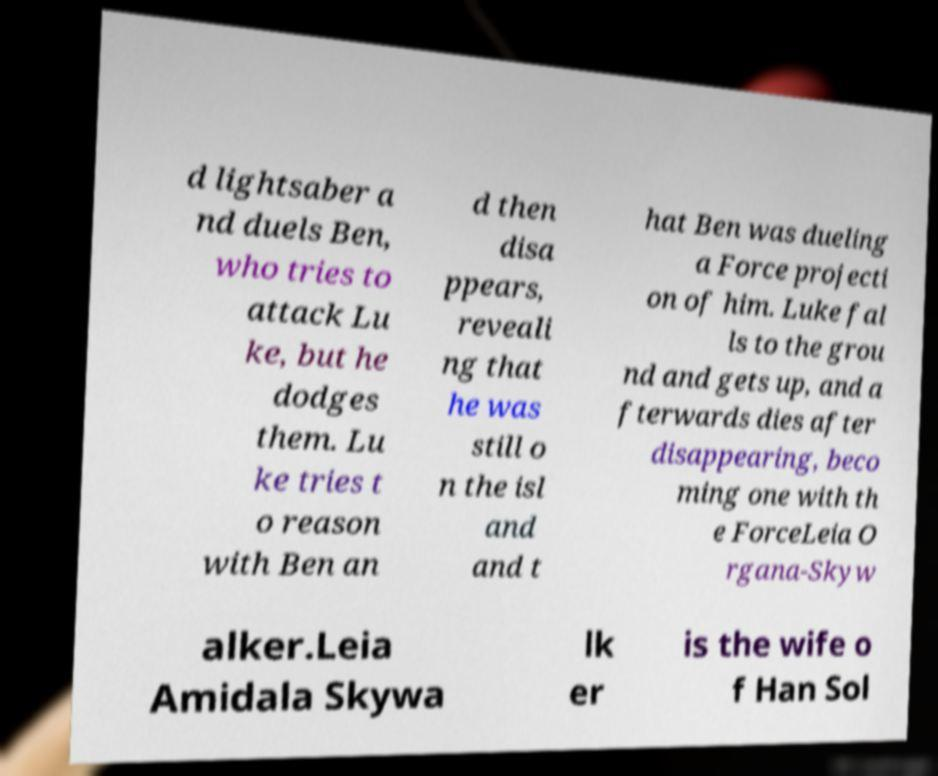What messages or text are displayed in this image? I need them in a readable, typed format. d lightsaber a nd duels Ben, who tries to attack Lu ke, but he dodges them. Lu ke tries t o reason with Ben an d then disa ppears, reveali ng that he was still o n the isl and and t hat Ben was dueling a Force projecti on of him. Luke fal ls to the grou nd and gets up, and a fterwards dies after disappearing, beco ming one with th e ForceLeia O rgana-Skyw alker.Leia Amidala Skywa lk er is the wife o f Han Sol 